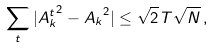Convert formula to latex. <formula><loc_0><loc_0><loc_500><loc_500>\sum _ { t } | { A _ { k } ^ { t } } ^ { 2 } - { A _ { k } } ^ { 2 } | \leq \sqrt { 2 } \, T \sqrt { N } \, ,</formula> 